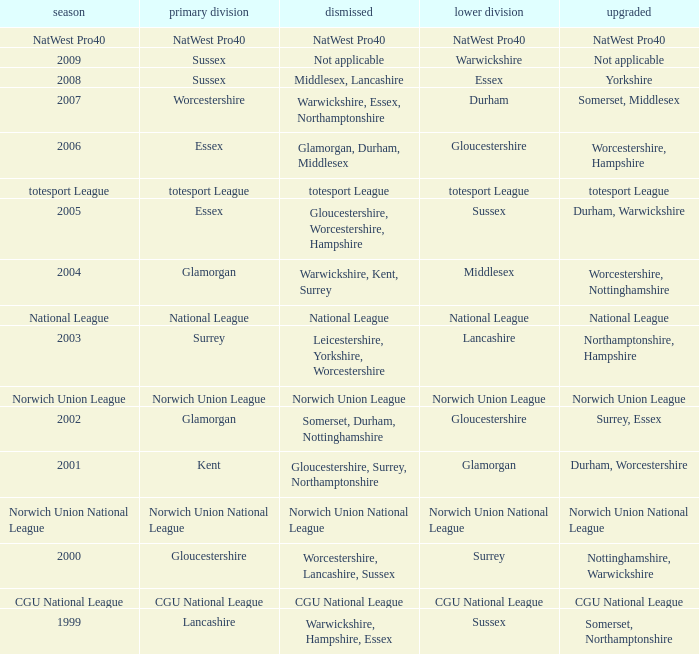What was relegated in the 2nd division of middlesex? Warwickshire, Kent, Surrey. 